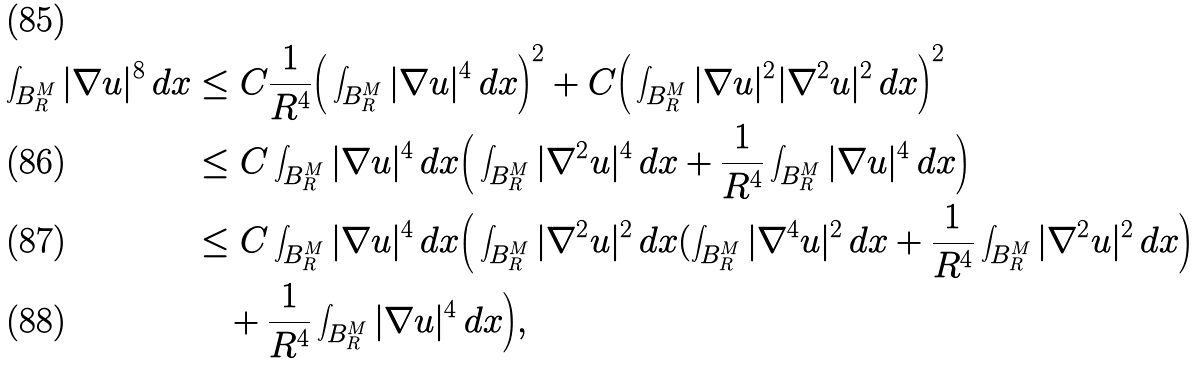<formula> <loc_0><loc_0><loc_500><loc_500>\int _ { B ^ { M } _ { R } } | \nabla u | ^ { 8 } \, d x & \leq C \frac { 1 } { R ^ { 4 } } \Big ( \int _ { B ^ { M } _ { R } } | \nabla u | ^ { 4 } \, d x \Big ) ^ { 2 } + C \Big ( \int _ { B ^ { M } _ { R } } | \nabla u | ^ { 2 } | \nabla ^ { 2 } u | ^ { 2 } \, d x \Big ) ^ { 2 } \\ & \leq C \int _ { B ^ { M } _ { R } } | \nabla u | ^ { 4 } \, d x \Big ( \int _ { B ^ { M } _ { R } } | \nabla ^ { 2 } u | ^ { 4 } \, d x + \frac { 1 } { R ^ { 4 } } \int _ { B ^ { M } _ { R } } | \nabla u | ^ { 4 } \, d x \Big ) \\ & \leq C \int _ { B ^ { M } _ { R } } | \nabla u | ^ { 4 } \, d x \Big ( \int _ { B ^ { M } _ { R } } | \nabla ^ { 2 } u | ^ { 2 } \, d x ( \int _ { B ^ { M } _ { R } } | \nabla ^ { 4 } u | ^ { 2 } \, d x + \frac { 1 } { R ^ { 4 } } \int _ { B ^ { M } _ { R } } | \nabla ^ { 2 } u | ^ { 2 } \, d x \Big ) \\ & \quad + \frac { 1 } { R ^ { 4 } } \int _ { B ^ { M } _ { R } } | \nabla u | ^ { 4 } \, d x \Big ) ,</formula> 